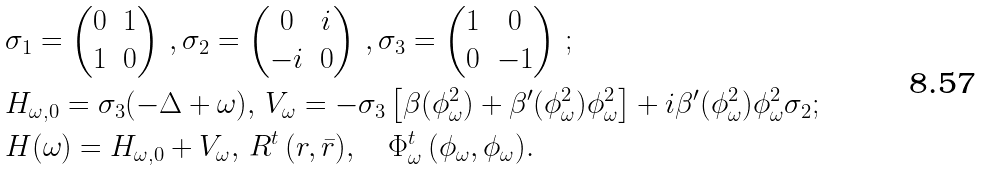<formula> <loc_0><loc_0><loc_500><loc_500>& \sigma _ { 1 } = \begin{pmatrix} 0 & 1 \\ 1 & 0 \end{pmatrix} \, , \sigma _ { 2 } = \begin{pmatrix} 0 & i \\ - i & 0 \end{pmatrix} \, , \sigma _ { 3 } = \begin{pmatrix} 1 & 0 \\ 0 & - 1 \end{pmatrix} \, ; \\ & H _ { \omega , 0 } = \sigma _ { 3 } ( - \Delta + \omega ) , \, V _ { \omega } = - \sigma _ { 3 } \left [ \beta ( \phi ^ { 2 } _ { \omega } ) + \beta ^ { \prime } ( \phi ^ { 2 } _ { \omega } ) \phi ^ { 2 } _ { \omega } \right ] + i \beta ^ { \prime } ( \phi ^ { 2 } _ { \omega } ) \phi ^ { 2 } _ { \omega } \sigma _ { 2 } ; \\ & H ( \omega ) = H _ { \omega , 0 } + V _ { \omega } , \, R ^ { t } \, ( r , \bar { r } ) , \quad \Phi _ { \omega } ^ { t } \, ( \phi _ { \omega } , \phi _ { \omega } ) .</formula> 